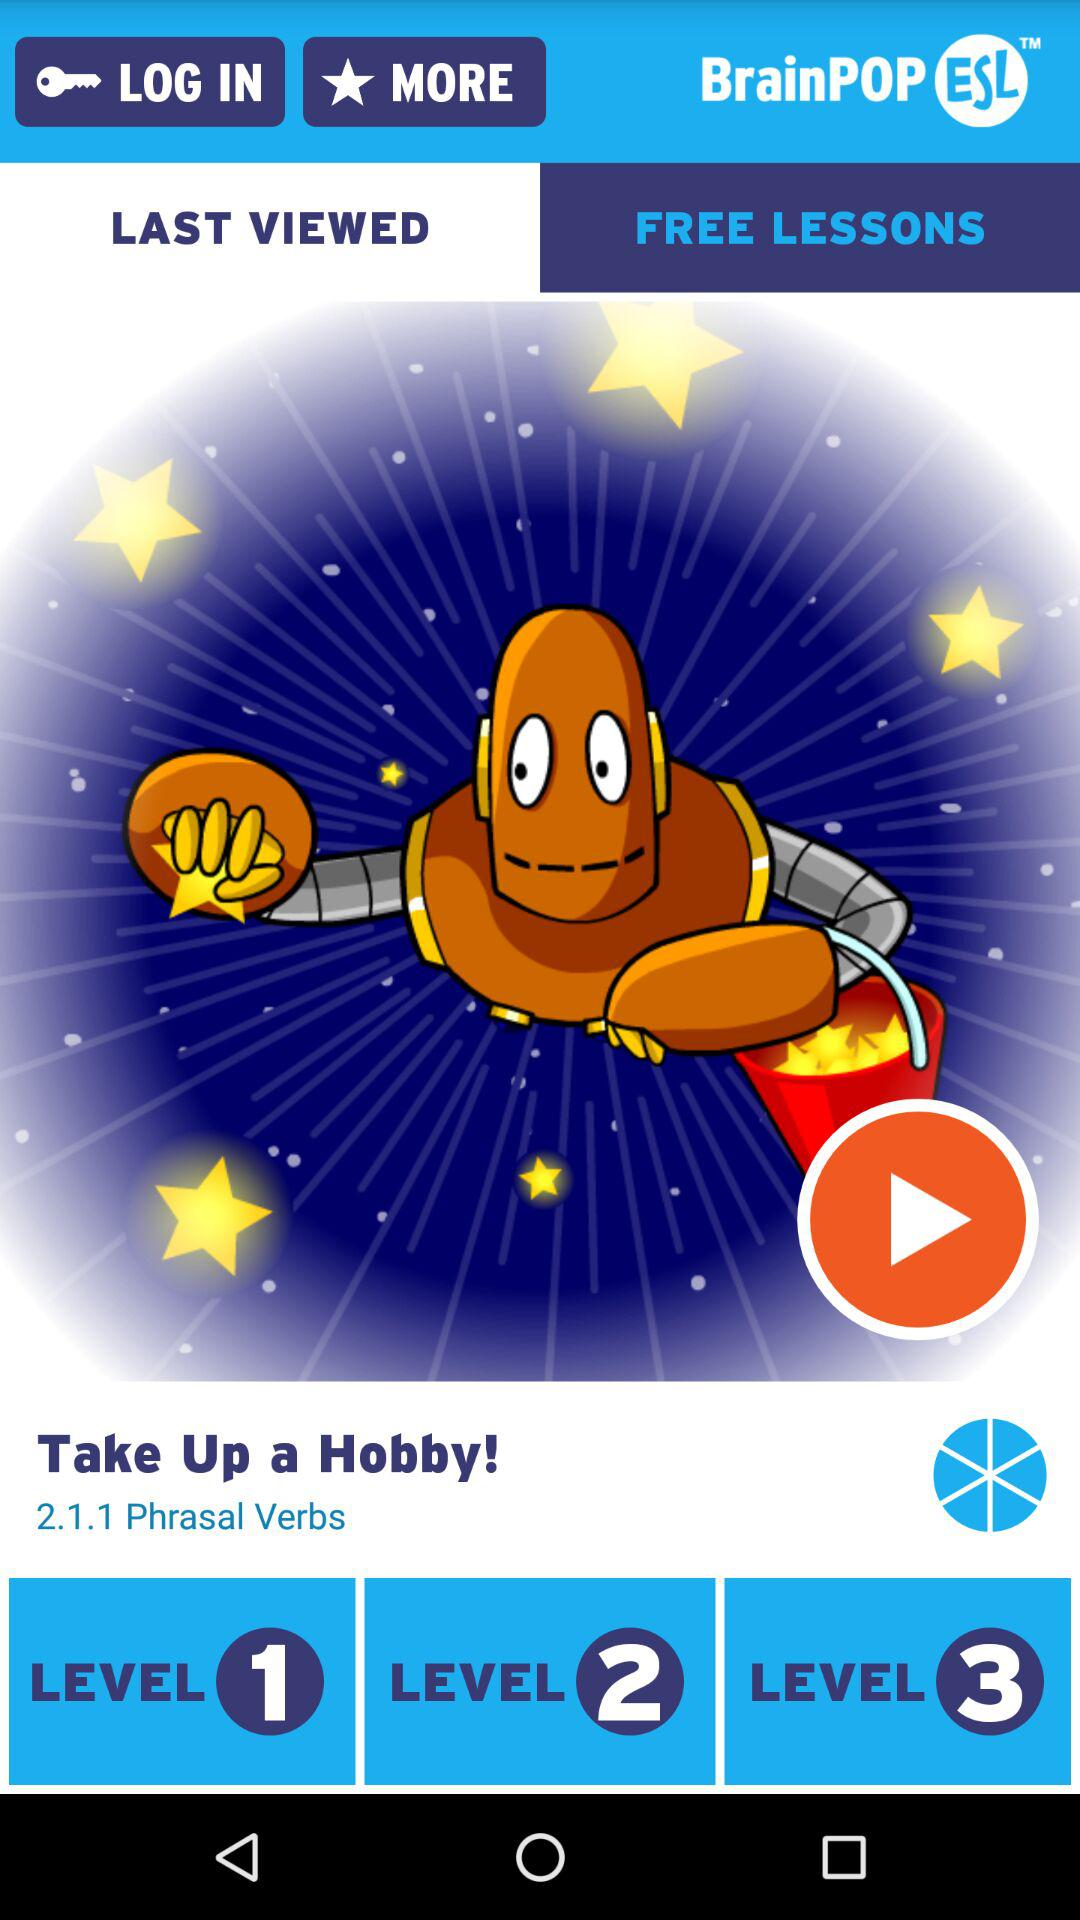How many levels are there in total?
Answer the question using a single word or phrase. 3 